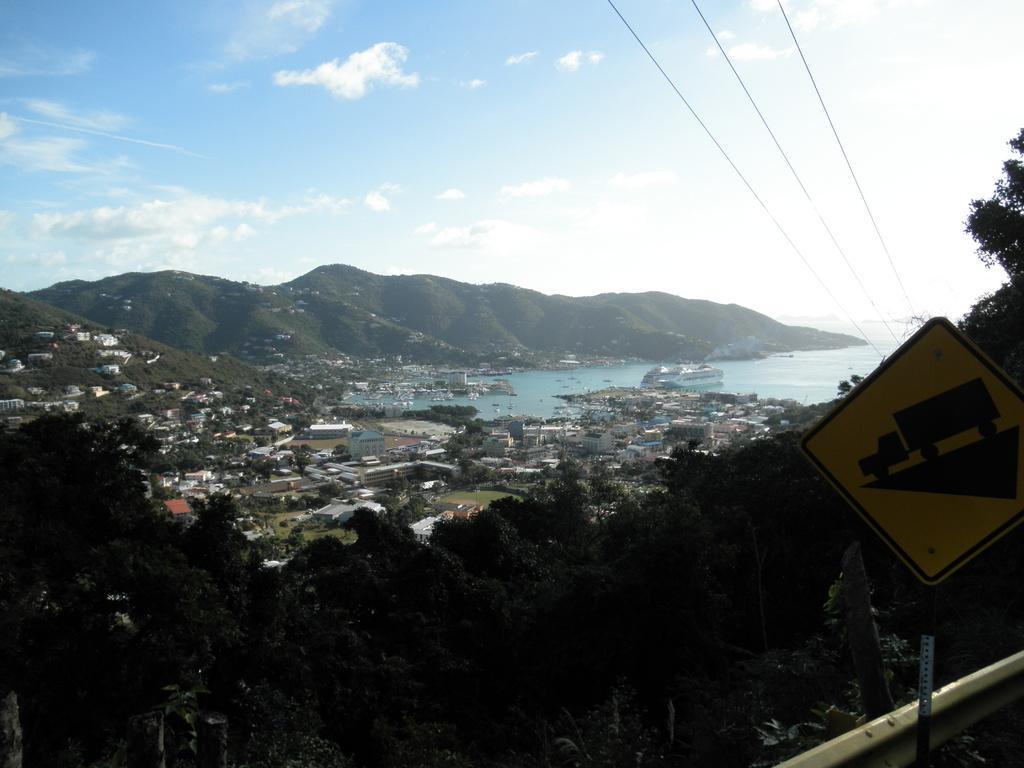How would you summarize this image in a sentence or two? In this picture there is a sign board attached to a pole behind it and there are trees,buildings,water and mountains in the background. 